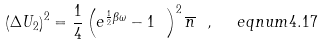<formula> <loc_0><loc_0><loc_500><loc_500>\left ( \Delta U _ { 2 } \right ) ^ { 2 } = \frac { 1 } { 4 } \left ( e ^ { \frac { 1 } { 2 } \beta \omega } - 1 \ \right ) ^ { 2 } \overline { n } \ , \ \ e q n u m { 4 . 1 7 }</formula> 